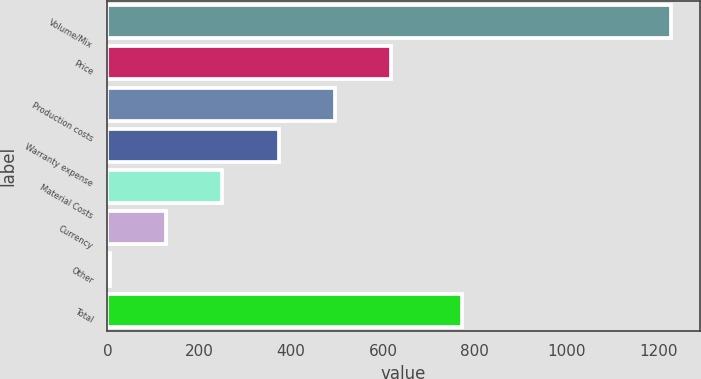Convert chart to OTSL. <chart><loc_0><loc_0><loc_500><loc_500><bar_chart><fcel>Volume/Mix<fcel>Price<fcel>Production costs<fcel>Warranty expense<fcel>Material Costs<fcel>Currency<fcel>Other<fcel>Total<nl><fcel>1228<fcel>617<fcel>494.8<fcel>372.6<fcel>250.4<fcel>128.2<fcel>6<fcel>771<nl></chart> 